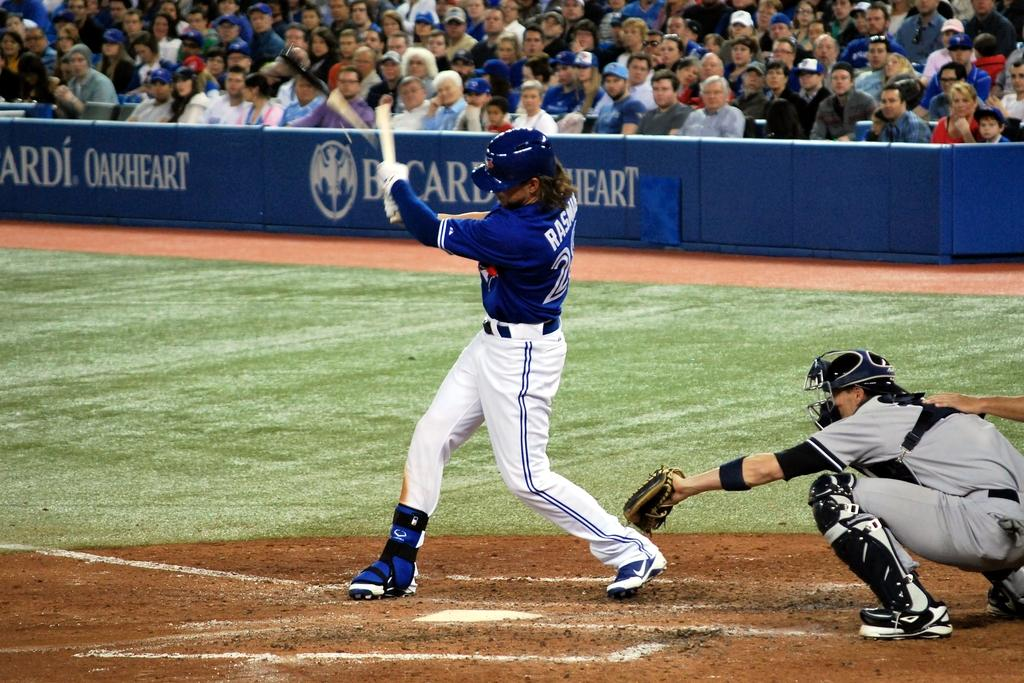Provide a one-sentence caption for the provided image. A batter swings at a pitch in a baseball game sponsored by Bacardi Oakheart. 